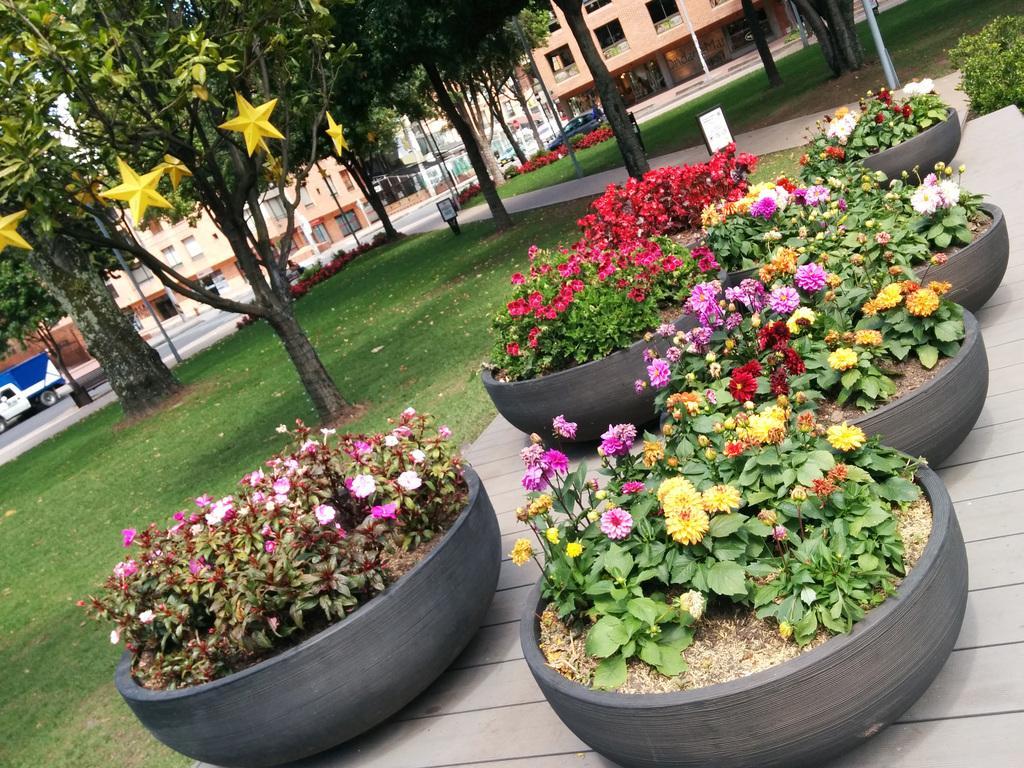Could you give a brief overview of what you see in this image? In the foreground, I can see house plants on the road, boards and grass. In the background, I can see trees, vehicles on the road, buildings, light poles and windows. This image taken, maybe in a park. 